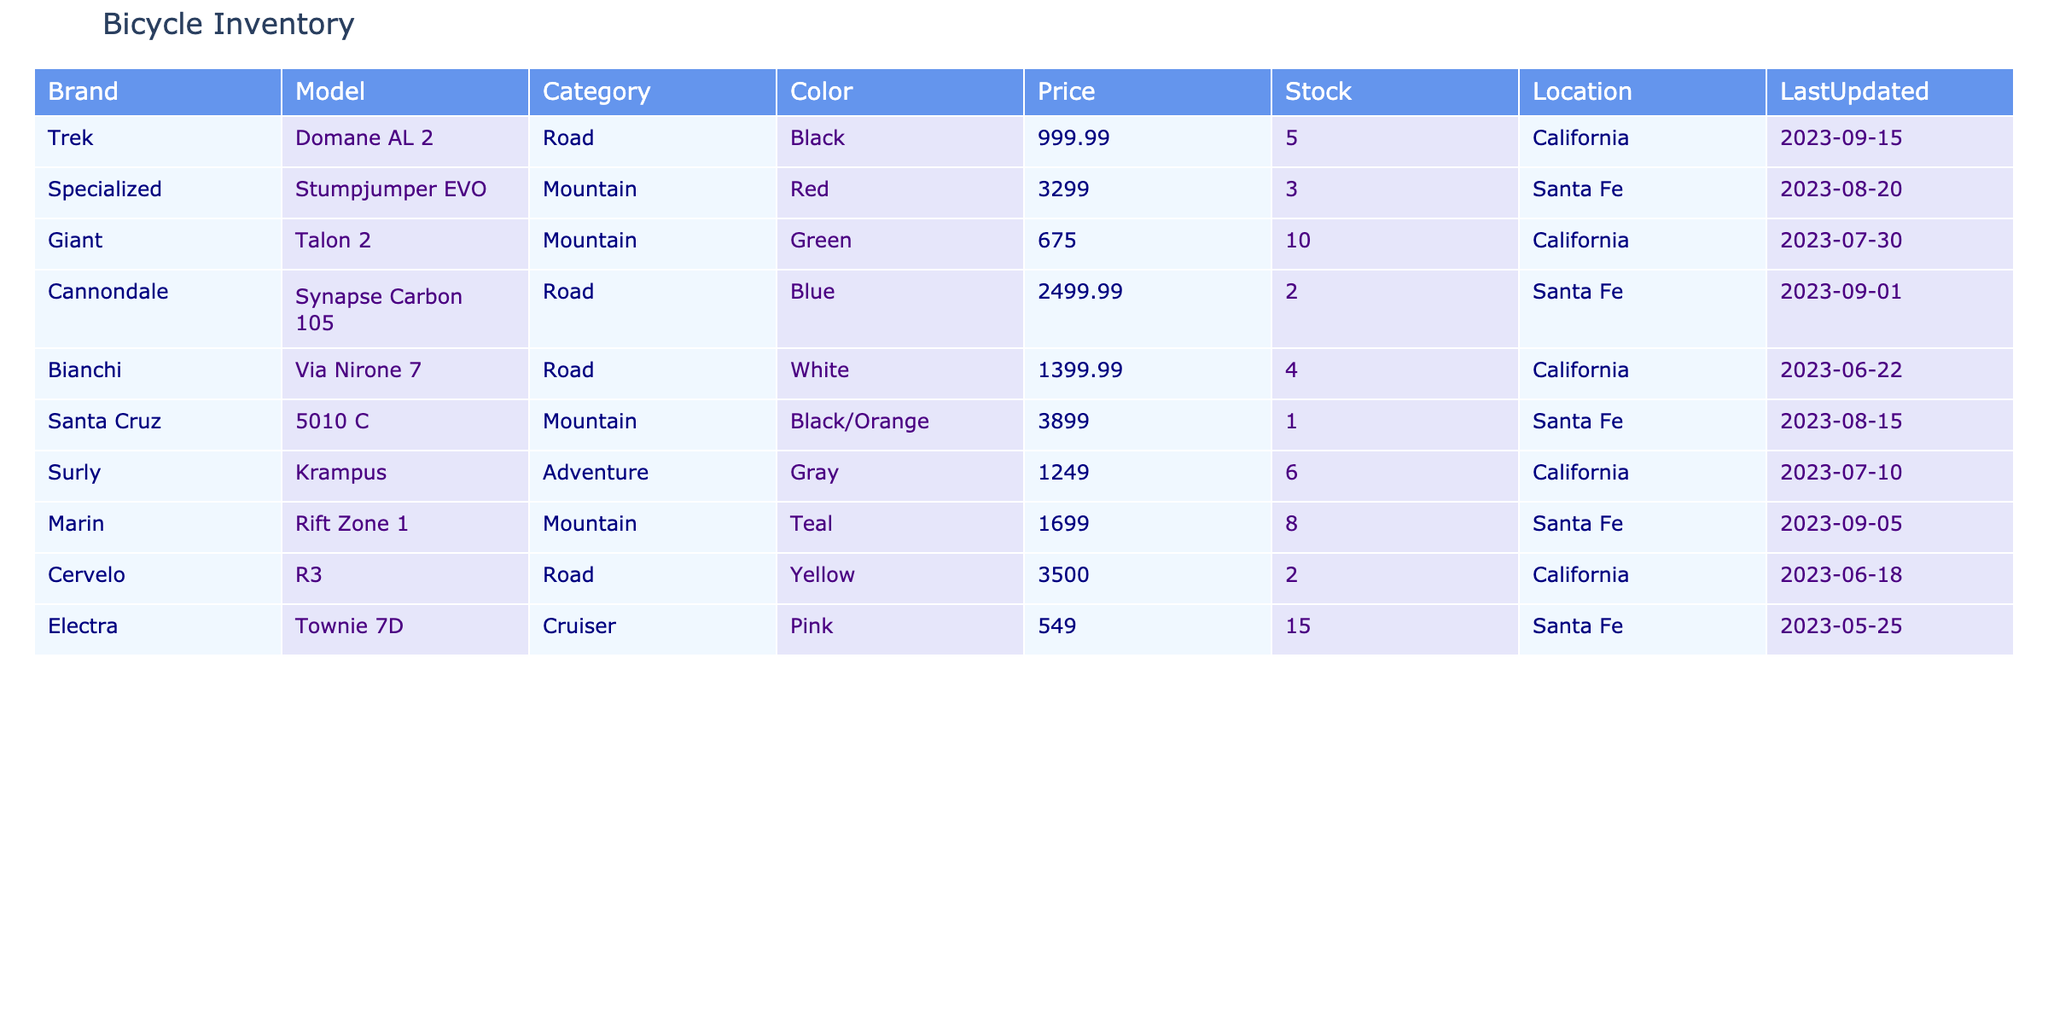What is the total stock of bicycles available in Santa Fe? In Santa Fe, the inventory shows three models: Specialized Stumpjumper EVO with a stock of 3, Santa Cruz 5010 C with a stock of 1, and Marin Rift Zone 1 with a stock of 8. Adding these together gives the total stock: 3 + 1 + 8 = 12.
Answer: 12 How many different brands of mountain bikes are listed? The mountain bikes in the table include models from Specialized, Giant, Santa Cruz, and Marin. This amounts to 4 different brands producing mountain bikes.
Answer: 4 Is there a road bike available in pink color? Checking the color of the road bikes listed, the Trek Domane AL 2 is black, Cannondale Synapse Carbon 105 is blue, Bianchi Via Nirone 7 is white, and Cervelo R3 is yellow. Thus, there is no road bike in pink.
Answer: No Which bicycle model has the highest price in the inventory? The prices of the bicycles are compared: Specialized Stumpjumper EVO is 3299.00, Santa Cruz 5010 C is 3899.00, and others fall below that. Santa Cruz 5010 C is the highest at 3899.00.
Answer: Santa Cruz 5010 C What is the total price of all road bikes listed? The road bikes' prices are: Trek Domane AL 2 at 999.99, Cannondale Synapse Carbon 105 at 2499.99, Bianchi Via Nirone 7 at 1399.99, and Cervelo R3 at 3500.00. Summing these gives a total: 999.99 + 2499.99 + 1399.99 + 3500.00 = 8800.00.
Answer: 8800.00 Are there more bicycles available in California than in Santa Fe? The total stock in California consists of Trek Domane AL 2 (5), Giant Talon 2 (10), and Surly Krampus (6), totaling 21. In Santa Fe, the total stock is 12. Thus, California has more.
Answer: Yes How many bikes in the inventory are categorized as adventure bikes? The inventory lists only one adventure bike, which is the Surly Krampus. Thus, the count of adventure bikes is 1.
Answer: 1 What is the average price of mountain bikes listed? The prices for mountain bikes are Specialized Stumpjumper EVO (3299.00), Giant Talon 2 (675.00), Santa Cruz 5010 C (3899.00), and Marin Rift Zone 1 (1699.00). This gives a total of 3299.00 + 675.00 + 3899.00 + 1699.00 = 10072.00. Dividing by the number of mountain bikes (4) gives an average price of 10072.00 / 4 = 2518.00.
Answer: 2518.00 